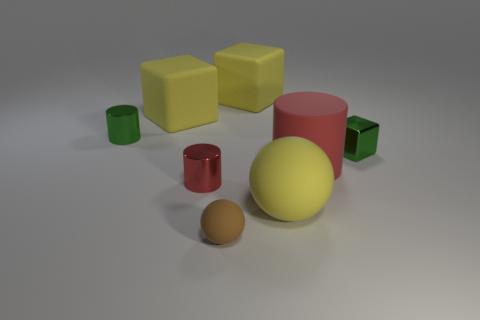Subtract all red metal cylinders. How many cylinders are left? 2 Subtract all purple balls. How many red cylinders are left? 2 Subtract all brown balls. How many balls are left? 1 Subtract all cylinders. How many objects are left? 5 Add 2 tiny rubber things. How many objects exist? 10 Subtract 3 cylinders. How many cylinders are left? 0 Subtract all red cylinders. Subtract all purple blocks. How many cylinders are left? 1 Subtract all big yellow blocks. Subtract all tiny red metallic cylinders. How many objects are left? 5 Add 6 tiny things. How many tiny things are left? 10 Add 3 tiny purple metallic things. How many tiny purple metallic things exist? 3 